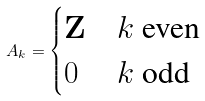Convert formula to latex. <formula><loc_0><loc_0><loc_500><loc_500>A _ { k } = \begin{cases} { \mathbf Z } & k \ \text {even} \\ 0 & k \ \text {odd} \end{cases}</formula> 